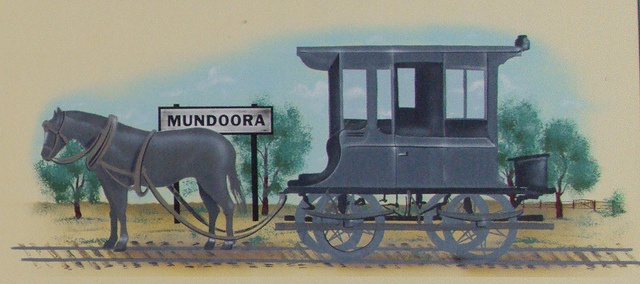Describe the objects in this image and their specific colors. I can see a horse in tan, gray, purple, and black tones in this image. 